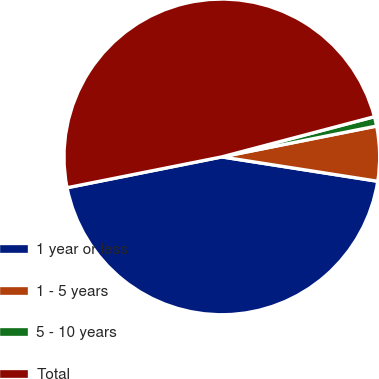Convert chart. <chart><loc_0><loc_0><loc_500><loc_500><pie_chart><fcel>1 year or less<fcel>1 - 5 years<fcel>5 - 10 years<fcel>Total<nl><fcel>44.4%<fcel>5.6%<fcel>0.97%<fcel>49.03%<nl></chart> 